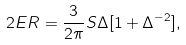Convert formula to latex. <formula><loc_0><loc_0><loc_500><loc_500>2 E R = \frac { 3 } { 2 \pi } S \Delta [ 1 + \Delta ^ { - 2 } ] ,</formula> 